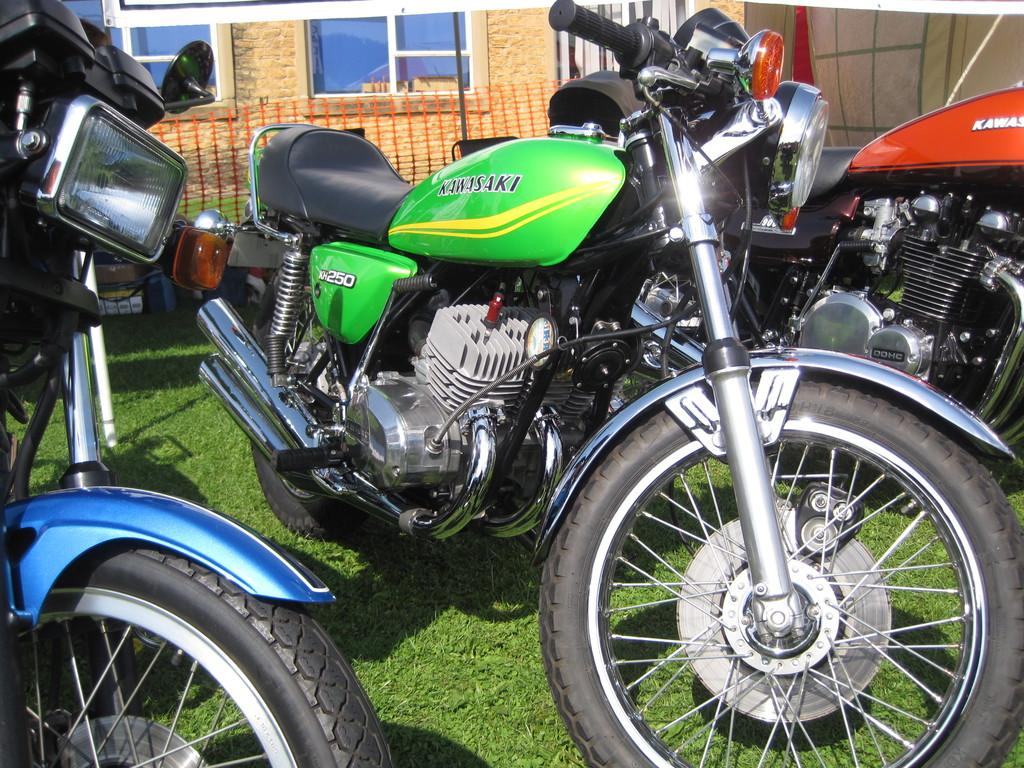How many bikes are parked in the image? There are three bikes parked in the image. What type of surface is at the bottom of the image? There is grass at the bottom of the image. What can be seen in the background of the image? There is a house in the background of the image. How many windows are visible in the image? There are two windows visible in the image. What type of powder is being used to clean the bikes in the image? There is no powder visible in the image, and the bikes do not appear to be in the process of being cleaned. 